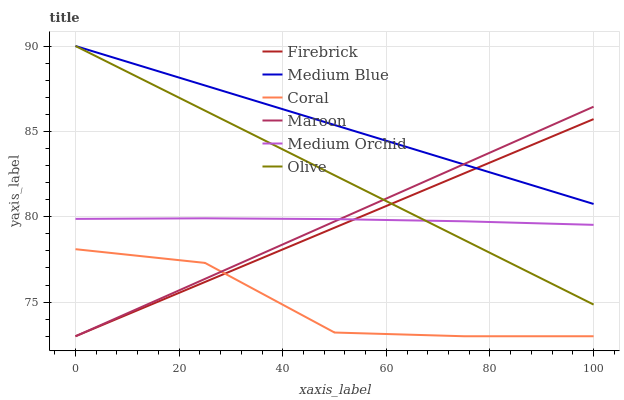Does Coral have the minimum area under the curve?
Answer yes or no. Yes. Does Medium Blue have the maximum area under the curve?
Answer yes or no. Yes. Does Medium Orchid have the minimum area under the curve?
Answer yes or no. No. Does Medium Orchid have the maximum area under the curve?
Answer yes or no. No. Is Olive the smoothest?
Answer yes or no. Yes. Is Coral the roughest?
Answer yes or no. Yes. Is Medium Orchid the smoothest?
Answer yes or no. No. Is Medium Orchid the roughest?
Answer yes or no. No. Does Medium Orchid have the lowest value?
Answer yes or no. No. Does Olive have the highest value?
Answer yes or no. Yes. Does Medium Orchid have the highest value?
Answer yes or no. No. Is Coral less than Medium Blue?
Answer yes or no. Yes. Is Medium Orchid greater than Coral?
Answer yes or no. Yes. Does Coral intersect Maroon?
Answer yes or no. Yes. Is Coral less than Maroon?
Answer yes or no. No. Is Coral greater than Maroon?
Answer yes or no. No. Does Coral intersect Medium Blue?
Answer yes or no. No. 